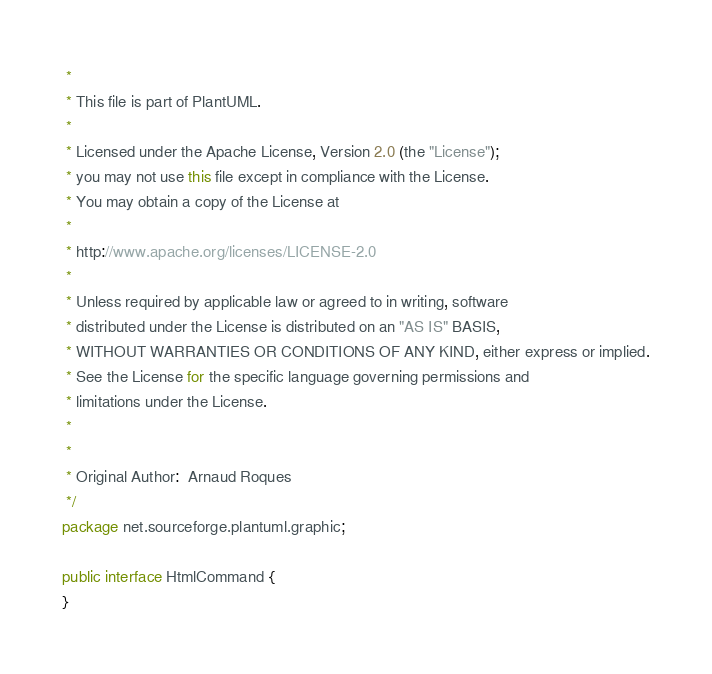<code> <loc_0><loc_0><loc_500><loc_500><_Java_> * 
 * This file is part of PlantUML.
 *
 * Licensed under the Apache License, Version 2.0 (the "License");
 * you may not use this file except in compliance with the License.
 * You may obtain a copy of the License at
 * 
 * http://www.apache.org/licenses/LICENSE-2.0
 * 
 * Unless required by applicable law or agreed to in writing, software
 * distributed under the License is distributed on an "AS IS" BASIS,
 * WITHOUT WARRANTIES OR CONDITIONS OF ANY KIND, either express or implied.
 * See the License for the specific language governing permissions and
 * limitations under the License.
 *
 *
 * Original Author:  Arnaud Roques
 */
package net.sourceforge.plantuml.graphic;

public interface HtmlCommand {
}
</code> 